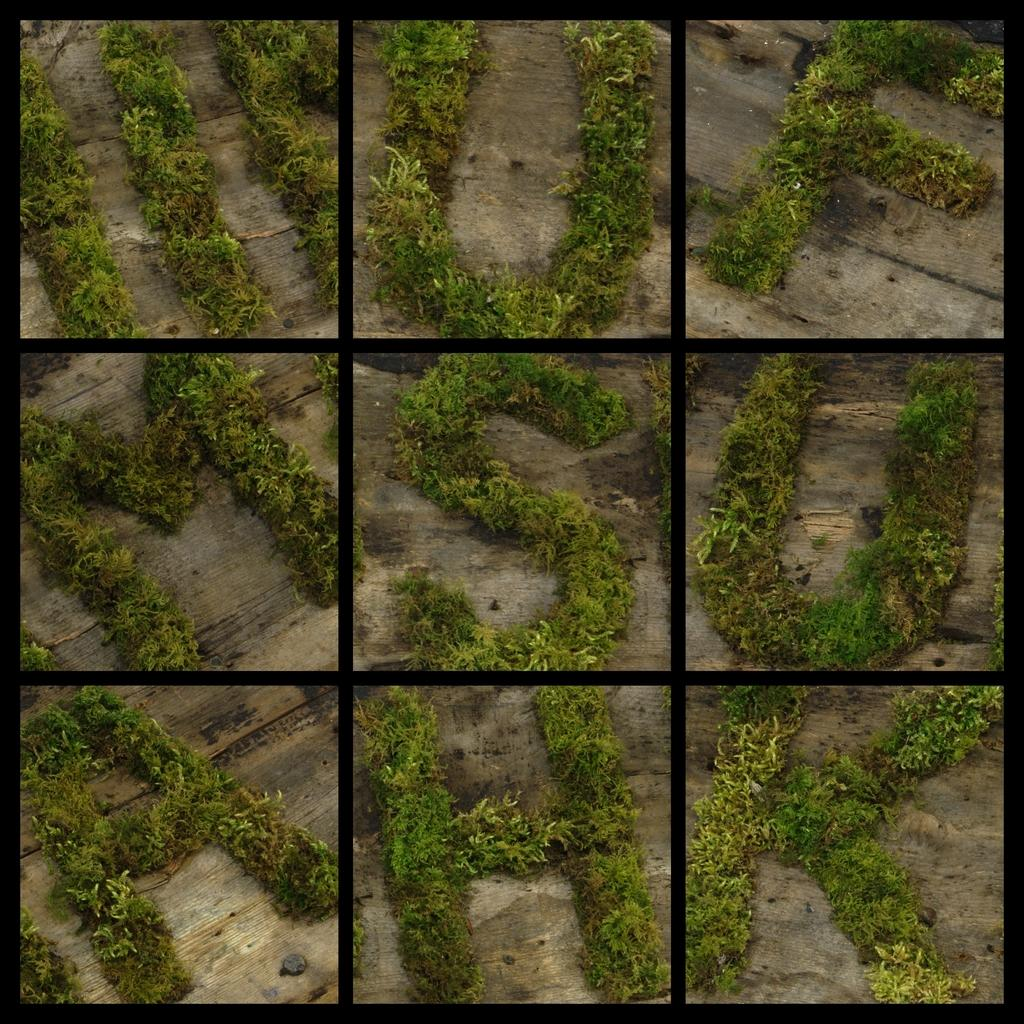What type of artwork is depicted in the image? The image is a collage of multiple images. What subjects are included in the collage? The collage includes images of plants. How are the plants arranged or designed in the collage? The plants are shaped in the form of alphabets. What type of fruit is depicted in the image? There is no fruit depicted in the image; it features a collage of plants shaped like alphabets. What religious symbols can be seen in the image? There are no religious symbols present in the image; it is a collage of plants shaped like alphabets. 